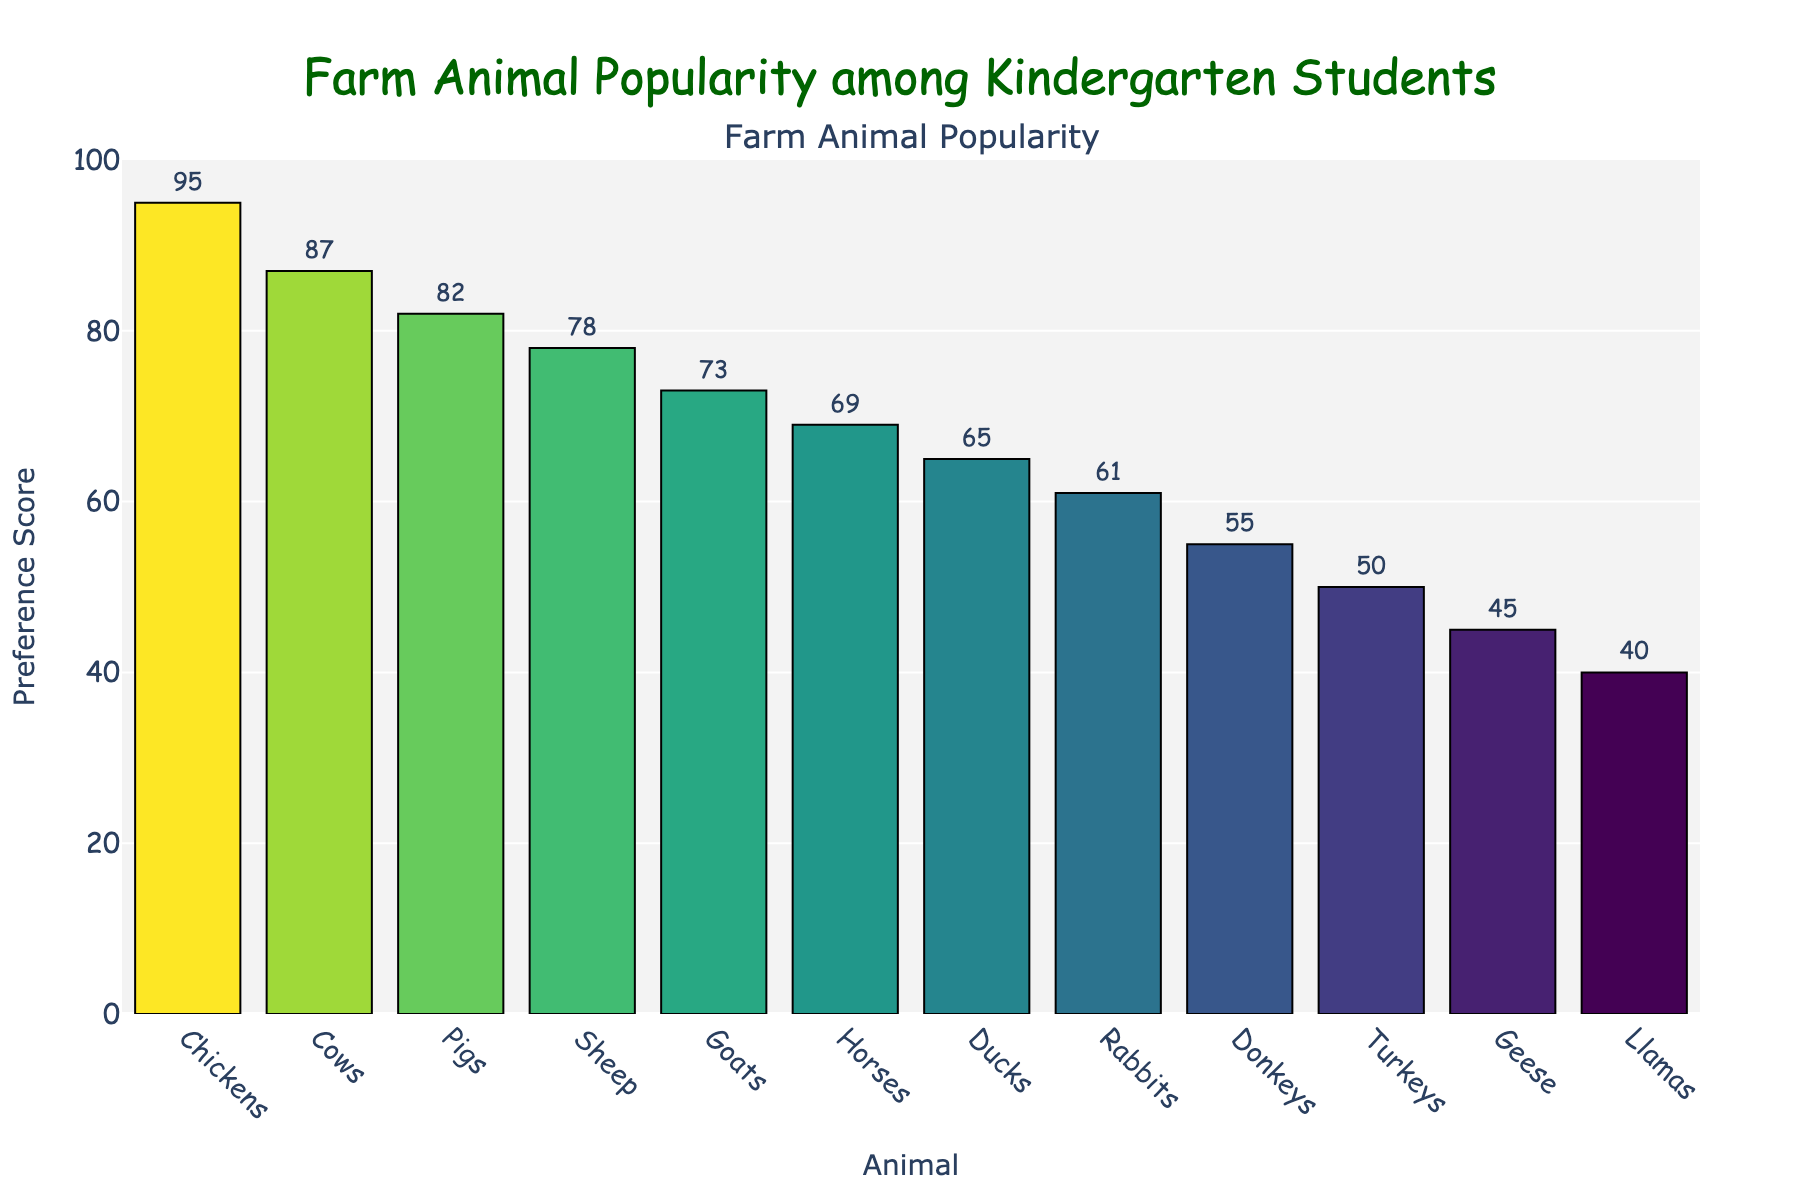Which animal is the most popular among the students? To find the most popular animal, we look for the bar with the highest height and the highest Preference Score. The highest bar corresponds to Chickens with a Preference Score of 95.
Answer: Chickens Which animal is the least popular among the students? To find the least popular animal, we look for the bar with the lowest height and the lowest Preference Score. The lowest bar corresponds to Llamas with a Preference Score of 40.
Answer: Llamas What is the combined preference score of Ducks, Rabbits, and Donkeys? First, locate the Preference Scores for Ducks (65), Rabbits (61), and Donkeys (55). Then, sum them up: 65 + 61 + 55 = 181.
Answer: 181 Are Cows or Goats more popular? Compare the Preference Scores of Cows and Goats. The Preference Score for Cows is 87, while for Goats, it is 73. Since 87 is greater than 73, Cows are more popular.
Answer: Cows What is the difference in preference score between the most and least popular animals? Determine the Preference Scores for the most popular (Chickens, 95) and the least popular (Llamas, 40) animals. Subtract the smallest score from the largest: 95 - 40 = 55.
Answer: 55 Which animals have a preference score less than 50? Identify all bars with heights corresponding to a Preference Score of less than 50. The animals that meet this criterion are Turkeys (50), Geese (45), and Llamas (40).
Answer: Turkeys, Geese, Llamas What is the average preference score of Chickens, Horses, and Sheep? First, find the Preference Scores for Chickens (95), Horses (69), and Sheep (78). Then, calculate the average: (95 + 69 + 78) / 3 = 242 / 3 = 80.67.
Answer: 80.67 Which animal has a preference score just below Pigs? Locate the Preference Score for Pigs (82), and find the animal with the next highest score below it. Sheep have a Preference Score of 78, which is just below Pigs.
Answer: Sheep 